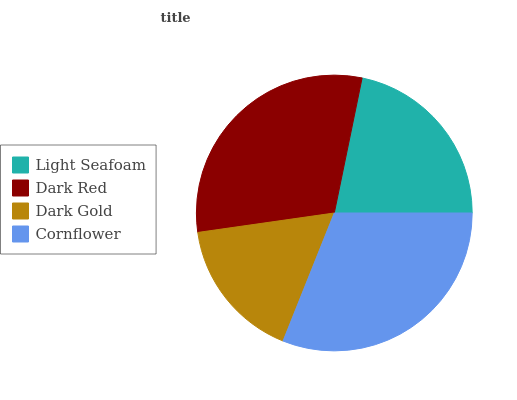Is Dark Gold the minimum?
Answer yes or no. Yes. Is Cornflower the maximum?
Answer yes or no. Yes. Is Dark Red the minimum?
Answer yes or no. No. Is Dark Red the maximum?
Answer yes or no. No. Is Dark Red greater than Light Seafoam?
Answer yes or no. Yes. Is Light Seafoam less than Dark Red?
Answer yes or no. Yes. Is Light Seafoam greater than Dark Red?
Answer yes or no. No. Is Dark Red less than Light Seafoam?
Answer yes or no. No. Is Dark Red the high median?
Answer yes or no. Yes. Is Light Seafoam the low median?
Answer yes or no. Yes. Is Cornflower the high median?
Answer yes or no. No. Is Dark Red the low median?
Answer yes or no. No. 